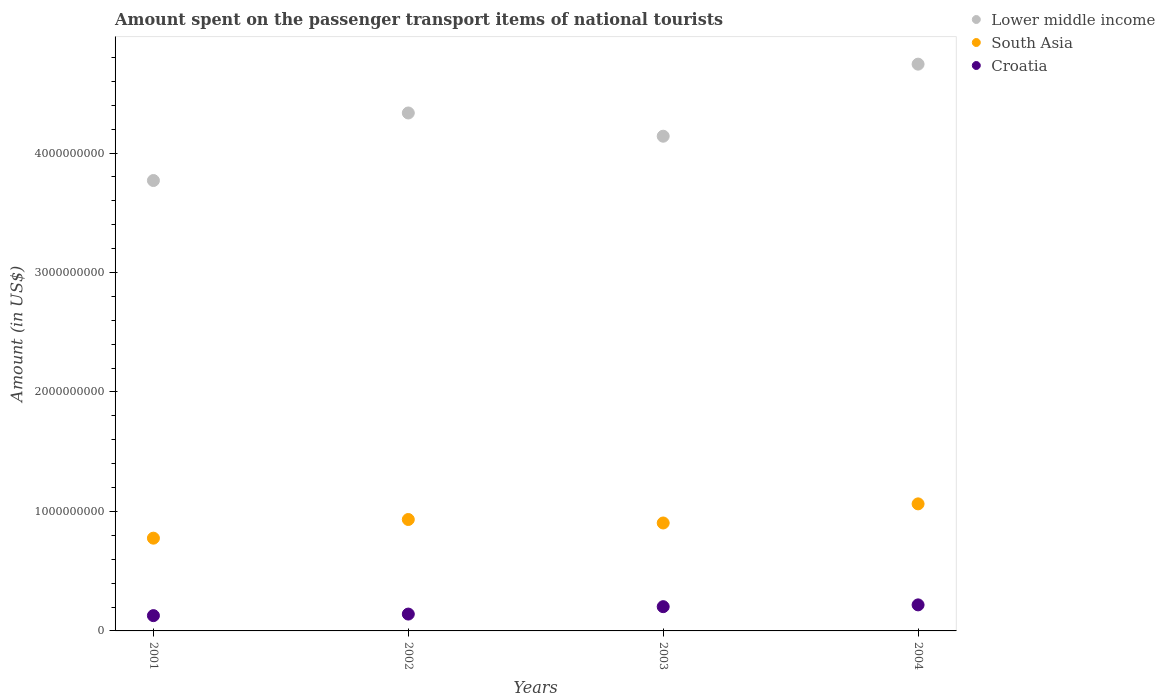How many different coloured dotlines are there?
Make the answer very short. 3. What is the amount spent on the passenger transport items of national tourists in South Asia in 2002?
Provide a short and direct response. 9.33e+08. Across all years, what is the maximum amount spent on the passenger transport items of national tourists in Lower middle income?
Offer a very short reply. 4.74e+09. Across all years, what is the minimum amount spent on the passenger transport items of national tourists in Croatia?
Your answer should be compact. 1.28e+08. In which year was the amount spent on the passenger transport items of national tourists in South Asia minimum?
Your response must be concise. 2001. What is the total amount spent on the passenger transport items of national tourists in Croatia in the graph?
Make the answer very short. 6.90e+08. What is the difference between the amount spent on the passenger transport items of national tourists in South Asia in 2001 and that in 2003?
Keep it short and to the point. -1.27e+08. What is the difference between the amount spent on the passenger transport items of national tourists in South Asia in 2004 and the amount spent on the passenger transport items of national tourists in Croatia in 2001?
Provide a succinct answer. 9.35e+08. What is the average amount spent on the passenger transport items of national tourists in Croatia per year?
Make the answer very short. 1.72e+08. In the year 2001, what is the difference between the amount spent on the passenger transport items of national tourists in South Asia and amount spent on the passenger transport items of national tourists in Croatia?
Your response must be concise. 6.48e+08. What is the ratio of the amount spent on the passenger transport items of national tourists in Lower middle income in 2003 to that in 2004?
Your answer should be compact. 0.87. Is the amount spent on the passenger transport items of national tourists in South Asia in 2002 less than that in 2004?
Offer a very short reply. Yes. What is the difference between the highest and the second highest amount spent on the passenger transport items of national tourists in Croatia?
Make the answer very short. 1.50e+07. What is the difference between the highest and the lowest amount spent on the passenger transport items of national tourists in Croatia?
Provide a succinct answer. 9.00e+07. In how many years, is the amount spent on the passenger transport items of national tourists in Croatia greater than the average amount spent on the passenger transport items of national tourists in Croatia taken over all years?
Your answer should be compact. 2. Is it the case that in every year, the sum of the amount spent on the passenger transport items of national tourists in South Asia and amount spent on the passenger transport items of national tourists in Croatia  is greater than the amount spent on the passenger transport items of national tourists in Lower middle income?
Your answer should be very brief. No. Does the amount spent on the passenger transport items of national tourists in South Asia monotonically increase over the years?
Give a very brief answer. No. How many years are there in the graph?
Give a very brief answer. 4. Does the graph contain any zero values?
Provide a short and direct response. No. How many legend labels are there?
Offer a very short reply. 3. What is the title of the graph?
Your answer should be very brief. Amount spent on the passenger transport items of national tourists. What is the label or title of the X-axis?
Your answer should be very brief. Years. What is the label or title of the Y-axis?
Ensure brevity in your answer.  Amount (in US$). What is the Amount (in US$) in Lower middle income in 2001?
Offer a very short reply. 3.77e+09. What is the Amount (in US$) of South Asia in 2001?
Keep it short and to the point. 7.76e+08. What is the Amount (in US$) in Croatia in 2001?
Offer a terse response. 1.28e+08. What is the Amount (in US$) in Lower middle income in 2002?
Your answer should be very brief. 4.34e+09. What is the Amount (in US$) in South Asia in 2002?
Provide a succinct answer. 9.33e+08. What is the Amount (in US$) of Croatia in 2002?
Offer a terse response. 1.41e+08. What is the Amount (in US$) of Lower middle income in 2003?
Your answer should be very brief. 4.14e+09. What is the Amount (in US$) in South Asia in 2003?
Provide a succinct answer. 9.03e+08. What is the Amount (in US$) of Croatia in 2003?
Provide a short and direct response. 2.03e+08. What is the Amount (in US$) of Lower middle income in 2004?
Your answer should be compact. 4.74e+09. What is the Amount (in US$) in South Asia in 2004?
Provide a short and direct response. 1.06e+09. What is the Amount (in US$) of Croatia in 2004?
Your answer should be compact. 2.18e+08. Across all years, what is the maximum Amount (in US$) of Lower middle income?
Give a very brief answer. 4.74e+09. Across all years, what is the maximum Amount (in US$) in South Asia?
Provide a succinct answer. 1.06e+09. Across all years, what is the maximum Amount (in US$) of Croatia?
Your answer should be very brief. 2.18e+08. Across all years, what is the minimum Amount (in US$) of Lower middle income?
Offer a terse response. 3.77e+09. Across all years, what is the minimum Amount (in US$) in South Asia?
Provide a succinct answer. 7.76e+08. Across all years, what is the minimum Amount (in US$) in Croatia?
Your response must be concise. 1.28e+08. What is the total Amount (in US$) in Lower middle income in the graph?
Make the answer very short. 1.70e+1. What is the total Amount (in US$) in South Asia in the graph?
Give a very brief answer. 3.68e+09. What is the total Amount (in US$) in Croatia in the graph?
Make the answer very short. 6.90e+08. What is the difference between the Amount (in US$) of Lower middle income in 2001 and that in 2002?
Keep it short and to the point. -5.65e+08. What is the difference between the Amount (in US$) in South Asia in 2001 and that in 2002?
Provide a short and direct response. -1.56e+08. What is the difference between the Amount (in US$) in Croatia in 2001 and that in 2002?
Provide a succinct answer. -1.30e+07. What is the difference between the Amount (in US$) in Lower middle income in 2001 and that in 2003?
Provide a short and direct response. -3.71e+08. What is the difference between the Amount (in US$) in South Asia in 2001 and that in 2003?
Make the answer very short. -1.27e+08. What is the difference between the Amount (in US$) in Croatia in 2001 and that in 2003?
Provide a short and direct response. -7.50e+07. What is the difference between the Amount (in US$) of Lower middle income in 2001 and that in 2004?
Provide a short and direct response. -9.74e+08. What is the difference between the Amount (in US$) of South Asia in 2001 and that in 2004?
Provide a succinct answer. -2.87e+08. What is the difference between the Amount (in US$) in Croatia in 2001 and that in 2004?
Provide a short and direct response. -9.00e+07. What is the difference between the Amount (in US$) in Lower middle income in 2002 and that in 2003?
Make the answer very short. 1.95e+08. What is the difference between the Amount (in US$) of South Asia in 2002 and that in 2003?
Offer a terse response. 2.92e+07. What is the difference between the Amount (in US$) in Croatia in 2002 and that in 2003?
Give a very brief answer. -6.20e+07. What is the difference between the Amount (in US$) of Lower middle income in 2002 and that in 2004?
Give a very brief answer. -4.09e+08. What is the difference between the Amount (in US$) in South Asia in 2002 and that in 2004?
Ensure brevity in your answer.  -1.31e+08. What is the difference between the Amount (in US$) in Croatia in 2002 and that in 2004?
Provide a succinct answer. -7.70e+07. What is the difference between the Amount (in US$) in Lower middle income in 2003 and that in 2004?
Keep it short and to the point. -6.03e+08. What is the difference between the Amount (in US$) of South Asia in 2003 and that in 2004?
Give a very brief answer. -1.60e+08. What is the difference between the Amount (in US$) in Croatia in 2003 and that in 2004?
Your answer should be compact. -1.50e+07. What is the difference between the Amount (in US$) in Lower middle income in 2001 and the Amount (in US$) in South Asia in 2002?
Offer a very short reply. 2.84e+09. What is the difference between the Amount (in US$) of Lower middle income in 2001 and the Amount (in US$) of Croatia in 2002?
Keep it short and to the point. 3.63e+09. What is the difference between the Amount (in US$) of South Asia in 2001 and the Amount (in US$) of Croatia in 2002?
Offer a terse response. 6.35e+08. What is the difference between the Amount (in US$) in Lower middle income in 2001 and the Amount (in US$) in South Asia in 2003?
Keep it short and to the point. 2.87e+09. What is the difference between the Amount (in US$) of Lower middle income in 2001 and the Amount (in US$) of Croatia in 2003?
Give a very brief answer. 3.57e+09. What is the difference between the Amount (in US$) of South Asia in 2001 and the Amount (in US$) of Croatia in 2003?
Offer a terse response. 5.73e+08. What is the difference between the Amount (in US$) of Lower middle income in 2001 and the Amount (in US$) of South Asia in 2004?
Give a very brief answer. 2.71e+09. What is the difference between the Amount (in US$) in Lower middle income in 2001 and the Amount (in US$) in Croatia in 2004?
Offer a very short reply. 3.55e+09. What is the difference between the Amount (in US$) of South Asia in 2001 and the Amount (in US$) of Croatia in 2004?
Ensure brevity in your answer.  5.58e+08. What is the difference between the Amount (in US$) of Lower middle income in 2002 and the Amount (in US$) of South Asia in 2003?
Give a very brief answer. 3.43e+09. What is the difference between the Amount (in US$) of Lower middle income in 2002 and the Amount (in US$) of Croatia in 2003?
Keep it short and to the point. 4.13e+09. What is the difference between the Amount (in US$) in South Asia in 2002 and the Amount (in US$) in Croatia in 2003?
Offer a terse response. 7.30e+08. What is the difference between the Amount (in US$) in Lower middle income in 2002 and the Amount (in US$) in South Asia in 2004?
Keep it short and to the point. 3.27e+09. What is the difference between the Amount (in US$) of Lower middle income in 2002 and the Amount (in US$) of Croatia in 2004?
Your response must be concise. 4.12e+09. What is the difference between the Amount (in US$) of South Asia in 2002 and the Amount (in US$) of Croatia in 2004?
Ensure brevity in your answer.  7.15e+08. What is the difference between the Amount (in US$) in Lower middle income in 2003 and the Amount (in US$) in South Asia in 2004?
Offer a very short reply. 3.08e+09. What is the difference between the Amount (in US$) in Lower middle income in 2003 and the Amount (in US$) in Croatia in 2004?
Offer a very short reply. 3.92e+09. What is the difference between the Amount (in US$) of South Asia in 2003 and the Amount (in US$) of Croatia in 2004?
Give a very brief answer. 6.85e+08. What is the average Amount (in US$) in Lower middle income per year?
Make the answer very short. 4.25e+09. What is the average Amount (in US$) of South Asia per year?
Provide a succinct answer. 9.19e+08. What is the average Amount (in US$) of Croatia per year?
Provide a short and direct response. 1.72e+08. In the year 2001, what is the difference between the Amount (in US$) of Lower middle income and Amount (in US$) of South Asia?
Your answer should be compact. 2.99e+09. In the year 2001, what is the difference between the Amount (in US$) of Lower middle income and Amount (in US$) of Croatia?
Provide a short and direct response. 3.64e+09. In the year 2001, what is the difference between the Amount (in US$) in South Asia and Amount (in US$) in Croatia?
Your answer should be compact. 6.48e+08. In the year 2002, what is the difference between the Amount (in US$) of Lower middle income and Amount (in US$) of South Asia?
Give a very brief answer. 3.40e+09. In the year 2002, what is the difference between the Amount (in US$) in Lower middle income and Amount (in US$) in Croatia?
Provide a short and direct response. 4.19e+09. In the year 2002, what is the difference between the Amount (in US$) of South Asia and Amount (in US$) of Croatia?
Provide a succinct answer. 7.92e+08. In the year 2003, what is the difference between the Amount (in US$) in Lower middle income and Amount (in US$) in South Asia?
Provide a short and direct response. 3.24e+09. In the year 2003, what is the difference between the Amount (in US$) of Lower middle income and Amount (in US$) of Croatia?
Give a very brief answer. 3.94e+09. In the year 2003, what is the difference between the Amount (in US$) of South Asia and Amount (in US$) of Croatia?
Provide a succinct answer. 7.00e+08. In the year 2004, what is the difference between the Amount (in US$) in Lower middle income and Amount (in US$) in South Asia?
Ensure brevity in your answer.  3.68e+09. In the year 2004, what is the difference between the Amount (in US$) in Lower middle income and Amount (in US$) in Croatia?
Ensure brevity in your answer.  4.53e+09. In the year 2004, what is the difference between the Amount (in US$) in South Asia and Amount (in US$) in Croatia?
Your answer should be compact. 8.45e+08. What is the ratio of the Amount (in US$) of Lower middle income in 2001 to that in 2002?
Provide a short and direct response. 0.87. What is the ratio of the Amount (in US$) in South Asia in 2001 to that in 2002?
Give a very brief answer. 0.83. What is the ratio of the Amount (in US$) of Croatia in 2001 to that in 2002?
Provide a succinct answer. 0.91. What is the ratio of the Amount (in US$) of Lower middle income in 2001 to that in 2003?
Your response must be concise. 0.91. What is the ratio of the Amount (in US$) of South Asia in 2001 to that in 2003?
Ensure brevity in your answer.  0.86. What is the ratio of the Amount (in US$) in Croatia in 2001 to that in 2003?
Provide a short and direct response. 0.63. What is the ratio of the Amount (in US$) of Lower middle income in 2001 to that in 2004?
Make the answer very short. 0.79. What is the ratio of the Amount (in US$) of South Asia in 2001 to that in 2004?
Offer a terse response. 0.73. What is the ratio of the Amount (in US$) in Croatia in 2001 to that in 2004?
Your answer should be very brief. 0.59. What is the ratio of the Amount (in US$) in Lower middle income in 2002 to that in 2003?
Provide a succinct answer. 1.05. What is the ratio of the Amount (in US$) of South Asia in 2002 to that in 2003?
Your answer should be very brief. 1.03. What is the ratio of the Amount (in US$) in Croatia in 2002 to that in 2003?
Provide a succinct answer. 0.69. What is the ratio of the Amount (in US$) in Lower middle income in 2002 to that in 2004?
Ensure brevity in your answer.  0.91. What is the ratio of the Amount (in US$) in South Asia in 2002 to that in 2004?
Provide a short and direct response. 0.88. What is the ratio of the Amount (in US$) of Croatia in 2002 to that in 2004?
Provide a short and direct response. 0.65. What is the ratio of the Amount (in US$) of Lower middle income in 2003 to that in 2004?
Ensure brevity in your answer.  0.87. What is the ratio of the Amount (in US$) in South Asia in 2003 to that in 2004?
Your answer should be compact. 0.85. What is the ratio of the Amount (in US$) in Croatia in 2003 to that in 2004?
Keep it short and to the point. 0.93. What is the difference between the highest and the second highest Amount (in US$) in Lower middle income?
Your answer should be compact. 4.09e+08. What is the difference between the highest and the second highest Amount (in US$) in South Asia?
Provide a short and direct response. 1.31e+08. What is the difference between the highest and the second highest Amount (in US$) of Croatia?
Make the answer very short. 1.50e+07. What is the difference between the highest and the lowest Amount (in US$) in Lower middle income?
Your answer should be very brief. 9.74e+08. What is the difference between the highest and the lowest Amount (in US$) in South Asia?
Ensure brevity in your answer.  2.87e+08. What is the difference between the highest and the lowest Amount (in US$) of Croatia?
Your answer should be compact. 9.00e+07. 